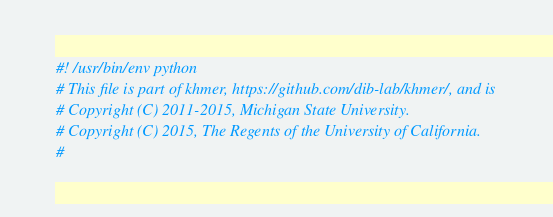<code> <loc_0><loc_0><loc_500><loc_500><_Python_>#! /usr/bin/env python
# This file is part of khmer, https://github.com/dib-lab/khmer/, and is
# Copyright (C) 2011-2015, Michigan State University.
# Copyright (C) 2015, The Regents of the University of California.
#</code> 